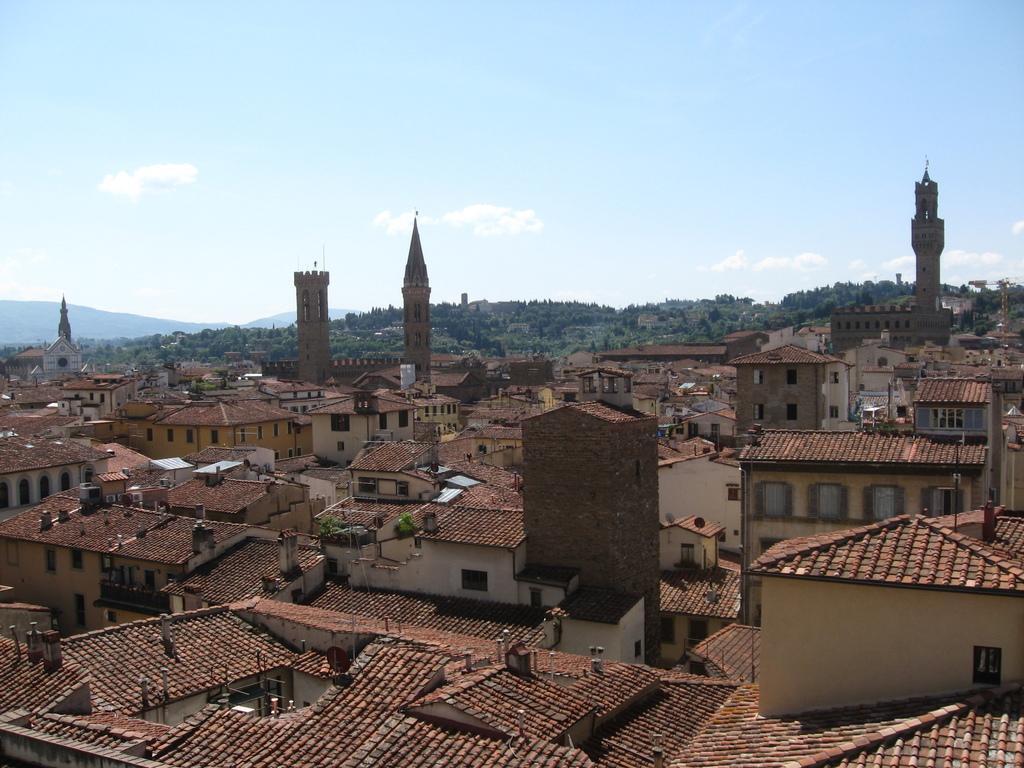Describe this image in one or two sentences. In this image I can see number of buildings. In the background I can see number of trees, clouds and the sky. 